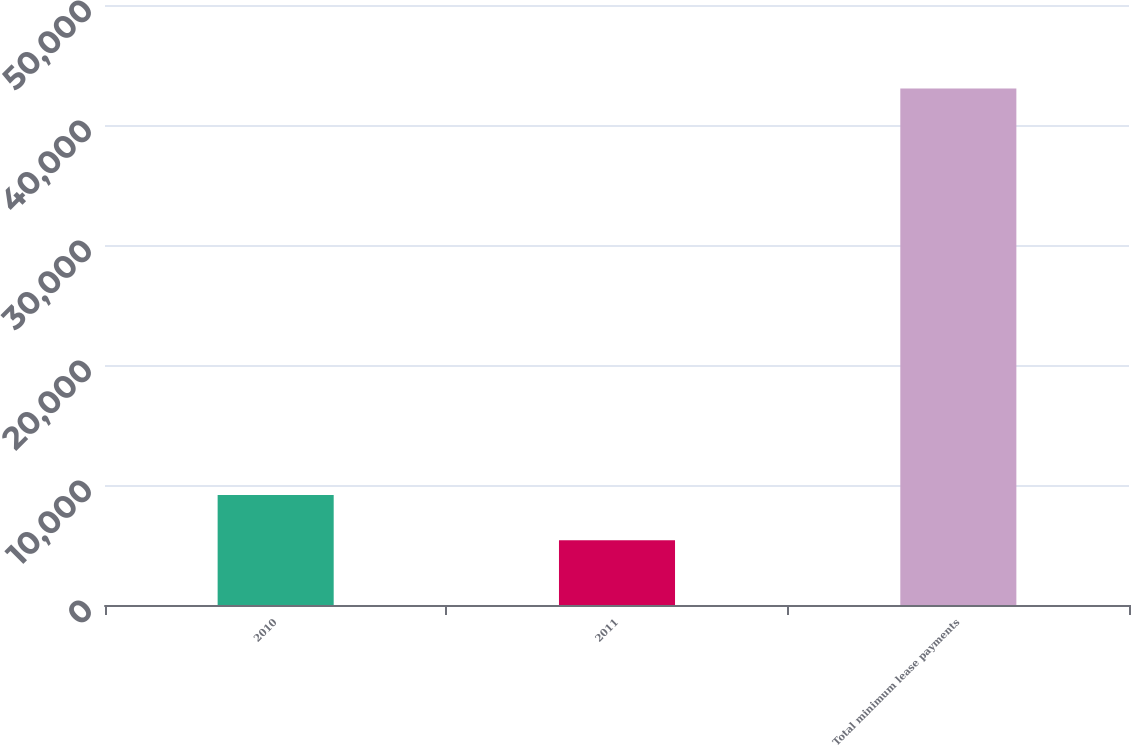<chart> <loc_0><loc_0><loc_500><loc_500><bar_chart><fcel>2010<fcel>2011<fcel>Total minimum lease payments<nl><fcel>9166.7<fcel>5403<fcel>43040<nl></chart> 